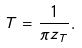Convert formula to latex. <formula><loc_0><loc_0><loc_500><loc_500>T = \frac { 1 } { \pi z _ { T } } .</formula> 